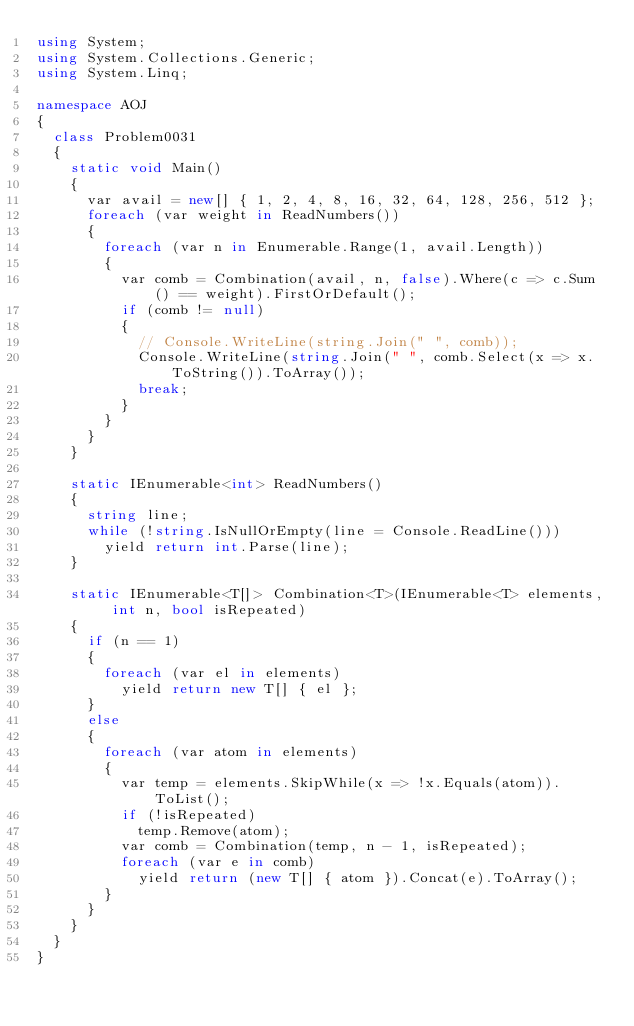Convert code to text. <code><loc_0><loc_0><loc_500><loc_500><_C#_>using System;
using System.Collections.Generic;
using System.Linq;

namespace AOJ
{
  class Problem0031
  {
    static void Main()
    {
      var avail = new[] { 1, 2, 4, 8, 16, 32, 64, 128, 256, 512 };
      foreach (var weight in ReadNumbers())
      {
        foreach (var n in Enumerable.Range(1, avail.Length))
        {
          var comb = Combination(avail, n, false).Where(c => c.Sum() == weight).FirstOrDefault();
          if (comb != null)
          {
            // Console.WriteLine(string.Join(" ", comb));
            Console.WriteLine(string.Join(" ", comb.Select(x => x.ToString()).ToArray());
            break;
          }
        }
      }
    }

    static IEnumerable<int> ReadNumbers()
    {
      string line;
      while (!string.IsNullOrEmpty(line = Console.ReadLine()))
        yield return int.Parse(line);
    }

    static IEnumerable<T[]> Combination<T>(IEnumerable<T> elements, int n, bool isRepeated)
    {
      if (n == 1)
      {
        foreach (var el in elements)
          yield return new T[] { el };
      }
      else
      {
        foreach (var atom in elements)
        {
          var temp = elements.SkipWhile(x => !x.Equals(atom)).ToList();
          if (!isRepeated)
            temp.Remove(atom);
          var comb = Combination(temp, n - 1, isRepeated);
          foreach (var e in comb)
            yield return (new T[] { atom }).Concat(e).ToArray();
        }
      }
    }
  }
}</code> 